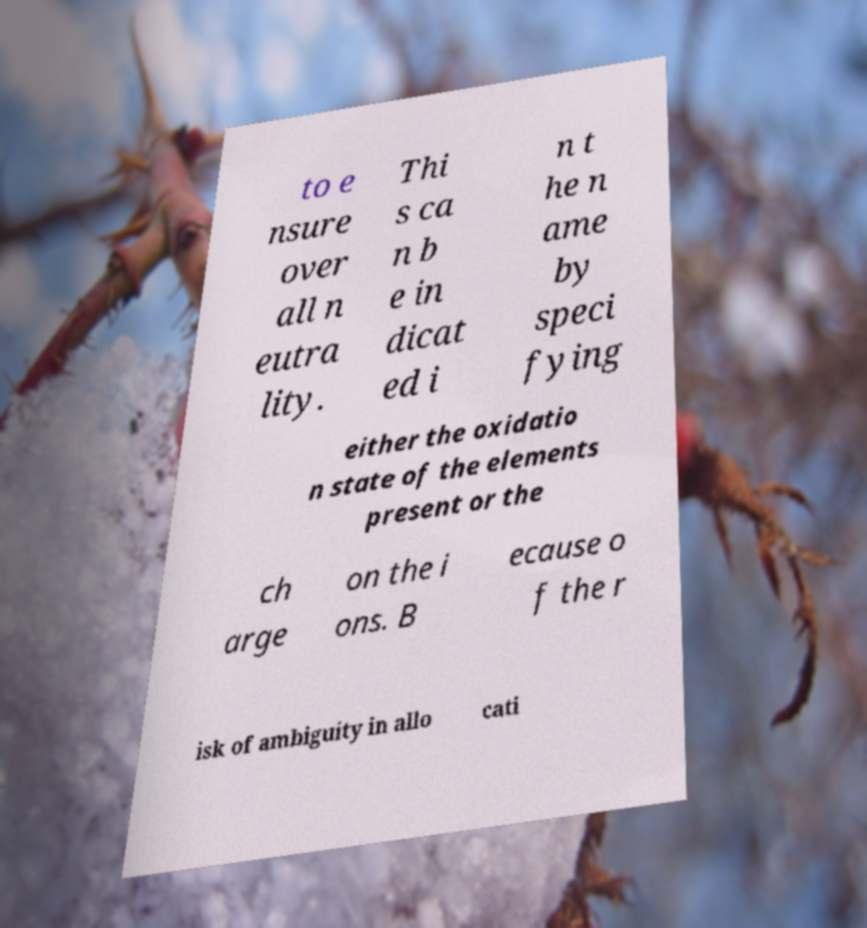Please read and relay the text visible in this image. What does it say? to e nsure over all n eutra lity. Thi s ca n b e in dicat ed i n t he n ame by speci fying either the oxidatio n state of the elements present or the ch arge on the i ons. B ecause o f the r isk of ambiguity in allo cati 